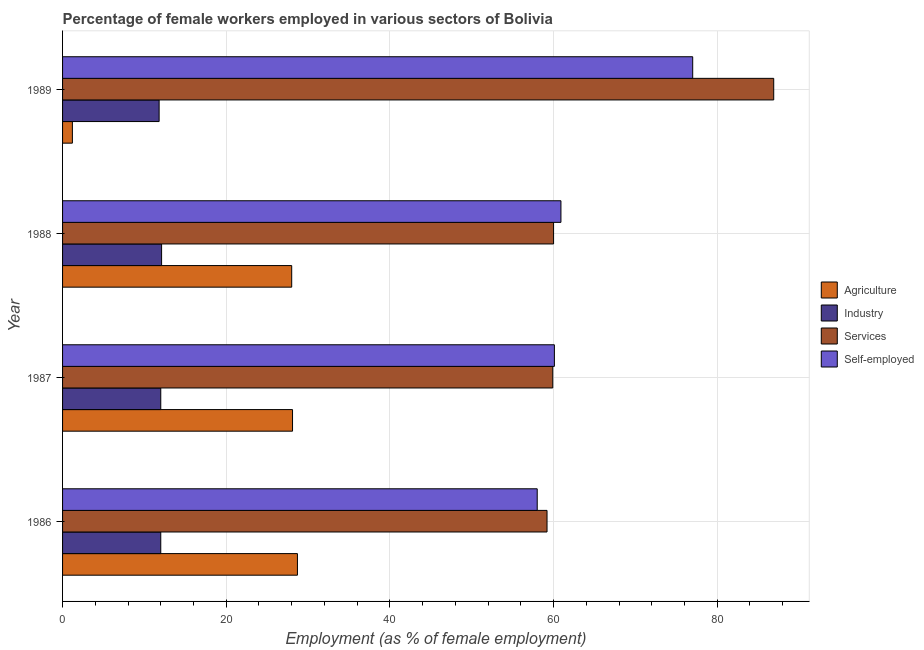How many bars are there on the 4th tick from the top?
Offer a terse response. 4. How many bars are there on the 2nd tick from the bottom?
Give a very brief answer. 4. What is the label of the 1st group of bars from the top?
Give a very brief answer. 1989. What is the percentage of female workers in services in 1987?
Offer a terse response. 59.9. Across all years, what is the maximum percentage of female workers in industry?
Offer a terse response. 12.1. Across all years, what is the minimum percentage of female workers in industry?
Ensure brevity in your answer.  11.8. In which year was the percentage of female workers in industry minimum?
Give a very brief answer. 1989. What is the total percentage of female workers in agriculture in the graph?
Offer a very short reply. 86. What is the difference between the percentage of female workers in agriculture in 1986 and the percentage of female workers in services in 1987?
Your answer should be compact. -31.2. What is the average percentage of female workers in agriculture per year?
Your answer should be compact. 21.5. In how many years, is the percentage of female workers in services greater than 28 %?
Your response must be concise. 4. What is the difference between the highest and the second highest percentage of female workers in services?
Ensure brevity in your answer.  26.9. Is the sum of the percentage of self employed female workers in 1986 and 1989 greater than the maximum percentage of female workers in industry across all years?
Offer a very short reply. Yes. Is it the case that in every year, the sum of the percentage of self employed female workers and percentage of female workers in agriculture is greater than the sum of percentage of female workers in industry and percentage of female workers in services?
Your response must be concise. Yes. What does the 4th bar from the top in 1988 represents?
Make the answer very short. Agriculture. What does the 3rd bar from the bottom in 1989 represents?
Your answer should be compact. Services. Is it the case that in every year, the sum of the percentage of female workers in agriculture and percentage of female workers in industry is greater than the percentage of female workers in services?
Offer a very short reply. No. Are all the bars in the graph horizontal?
Provide a succinct answer. Yes. How many years are there in the graph?
Provide a short and direct response. 4. What is the difference between two consecutive major ticks on the X-axis?
Give a very brief answer. 20. Does the graph contain grids?
Give a very brief answer. Yes. Where does the legend appear in the graph?
Offer a terse response. Center right. What is the title of the graph?
Your answer should be very brief. Percentage of female workers employed in various sectors of Bolivia. Does "International Development Association" appear as one of the legend labels in the graph?
Your answer should be very brief. No. What is the label or title of the X-axis?
Provide a short and direct response. Employment (as % of female employment). What is the Employment (as % of female employment) of Agriculture in 1986?
Your answer should be very brief. 28.7. What is the Employment (as % of female employment) of Services in 1986?
Keep it short and to the point. 59.2. What is the Employment (as % of female employment) of Agriculture in 1987?
Give a very brief answer. 28.1. What is the Employment (as % of female employment) of Industry in 1987?
Ensure brevity in your answer.  12. What is the Employment (as % of female employment) in Services in 1987?
Keep it short and to the point. 59.9. What is the Employment (as % of female employment) in Self-employed in 1987?
Offer a terse response. 60.1. What is the Employment (as % of female employment) of Agriculture in 1988?
Offer a very short reply. 28. What is the Employment (as % of female employment) in Industry in 1988?
Your response must be concise. 12.1. What is the Employment (as % of female employment) of Services in 1988?
Offer a very short reply. 60. What is the Employment (as % of female employment) of Self-employed in 1988?
Your response must be concise. 60.9. What is the Employment (as % of female employment) of Agriculture in 1989?
Keep it short and to the point. 1.2. What is the Employment (as % of female employment) of Industry in 1989?
Your answer should be very brief. 11.8. What is the Employment (as % of female employment) of Services in 1989?
Offer a terse response. 86.9. What is the Employment (as % of female employment) in Self-employed in 1989?
Ensure brevity in your answer.  77. Across all years, what is the maximum Employment (as % of female employment) of Agriculture?
Your answer should be compact. 28.7. Across all years, what is the maximum Employment (as % of female employment) of Industry?
Your answer should be very brief. 12.1. Across all years, what is the maximum Employment (as % of female employment) of Services?
Give a very brief answer. 86.9. Across all years, what is the minimum Employment (as % of female employment) in Agriculture?
Ensure brevity in your answer.  1.2. Across all years, what is the minimum Employment (as % of female employment) of Industry?
Offer a very short reply. 11.8. Across all years, what is the minimum Employment (as % of female employment) of Services?
Offer a terse response. 59.2. What is the total Employment (as % of female employment) of Industry in the graph?
Ensure brevity in your answer.  47.9. What is the total Employment (as % of female employment) in Services in the graph?
Keep it short and to the point. 266. What is the total Employment (as % of female employment) of Self-employed in the graph?
Your response must be concise. 256. What is the difference between the Employment (as % of female employment) of Agriculture in 1986 and that in 1987?
Provide a short and direct response. 0.6. What is the difference between the Employment (as % of female employment) in Industry in 1986 and that in 1987?
Offer a very short reply. 0. What is the difference between the Employment (as % of female employment) of Services in 1986 and that in 1987?
Keep it short and to the point. -0.7. What is the difference between the Employment (as % of female employment) of Self-employed in 1986 and that in 1987?
Make the answer very short. -2.1. What is the difference between the Employment (as % of female employment) of Agriculture in 1986 and that in 1989?
Make the answer very short. 27.5. What is the difference between the Employment (as % of female employment) in Services in 1986 and that in 1989?
Offer a terse response. -27.7. What is the difference between the Employment (as % of female employment) in Agriculture in 1987 and that in 1988?
Your answer should be compact. 0.1. What is the difference between the Employment (as % of female employment) in Industry in 1987 and that in 1988?
Make the answer very short. -0.1. What is the difference between the Employment (as % of female employment) of Services in 1987 and that in 1988?
Offer a very short reply. -0.1. What is the difference between the Employment (as % of female employment) of Agriculture in 1987 and that in 1989?
Offer a terse response. 26.9. What is the difference between the Employment (as % of female employment) in Industry in 1987 and that in 1989?
Your answer should be very brief. 0.2. What is the difference between the Employment (as % of female employment) in Services in 1987 and that in 1989?
Make the answer very short. -27. What is the difference between the Employment (as % of female employment) of Self-employed in 1987 and that in 1989?
Keep it short and to the point. -16.9. What is the difference between the Employment (as % of female employment) of Agriculture in 1988 and that in 1989?
Provide a succinct answer. 26.8. What is the difference between the Employment (as % of female employment) in Services in 1988 and that in 1989?
Offer a very short reply. -26.9. What is the difference between the Employment (as % of female employment) of Self-employed in 1988 and that in 1989?
Your answer should be compact. -16.1. What is the difference between the Employment (as % of female employment) in Agriculture in 1986 and the Employment (as % of female employment) in Industry in 1987?
Give a very brief answer. 16.7. What is the difference between the Employment (as % of female employment) of Agriculture in 1986 and the Employment (as % of female employment) of Services in 1987?
Ensure brevity in your answer.  -31.2. What is the difference between the Employment (as % of female employment) of Agriculture in 1986 and the Employment (as % of female employment) of Self-employed in 1987?
Keep it short and to the point. -31.4. What is the difference between the Employment (as % of female employment) of Industry in 1986 and the Employment (as % of female employment) of Services in 1987?
Make the answer very short. -47.9. What is the difference between the Employment (as % of female employment) of Industry in 1986 and the Employment (as % of female employment) of Self-employed in 1987?
Offer a terse response. -48.1. What is the difference between the Employment (as % of female employment) in Agriculture in 1986 and the Employment (as % of female employment) in Services in 1988?
Your response must be concise. -31.3. What is the difference between the Employment (as % of female employment) in Agriculture in 1986 and the Employment (as % of female employment) in Self-employed in 1988?
Your answer should be very brief. -32.2. What is the difference between the Employment (as % of female employment) of Industry in 1986 and the Employment (as % of female employment) of Services in 1988?
Ensure brevity in your answer.  -48. What is the difference between the Employment (as % of female employment) of Industry in 1986 and the Employment (as % of female employment) of Self-employed in 1988?
Give a very brief answer. -48.9. What is the difference between the Employment (as % of female employment) in Agriculture in 1986 and the Employment (as % of female employment) in Services in 1989?
Your answer should be very brief. -58.2. What is the difference between the Employment (as % of female employment) of Agriculture in 1986 and the Employment (as % of female employment) of Self-employed in 1989?
Offer a very short reply. -48.3. What is the difference between the Employment (as % of female employment) of Industry in 1986 and the Employment (as % of female employment) of Services in 1989?
Offer a very short reply. -74.9. What is the difference between the Employment (as % of female employment) of Industry in 1986 and the Employment (as % of female employment) of Self-employed in 1989?
Offer a terse response. -65. What is the difference between the Employment (as % of female employment) in Services in 1986 and the Employment (as % of female employment) in Self-employed in 1989?
Offer a terse response. -17.8. What is the difference between the Employment (as % of female employment) of Agriculture in 1987 and the Employment (as % of female employment) of Industry in 1988?
Your response must be concise. 16. What is the difference between the Employment (as % of female employment) of Agriculture in 1987 and the Employment (as % of female employment) of Services in 1988?
Your answer should be compact. -31.9. What is the difference between the Employment (as % of female employment) in Agriculture in 1987 and the Employment (as % of female employment) in Self-employed in 1988?
Provide a succinct answer. -32.8. What is the difference between the Employment (as % of female employment) in Industry in 1987 and the Employment (as % of female employment) in Services in 1988?
Make the answer very short. -48. What is the difference between the Employment (as % of female employment) of Industry in 1987 and the Employment (as % of female employment) of Self-employed in 1988?
Your answer should be compact. -48.9. What is the difference between the Employment (as % of female employment) in Services in 1987 and the Employment (as % of female employment) in Self-employed in 1988?
Provide a short and direct response. -1. What is the difference between the Employment (as % of female employment) of Agriculture in 1987 and the Employment (as % of female employment) of Industry in 1989?
Your answer should be very brief. 16.3. What is the difference between the Employment (as % of female employment) in Agriculture in 1987 and the Employment (as % of female employment) in Services in 1989?
Offer a terse response. -58.8. What is the difference between the Employment (as % of female employment) of Agriculture in 1987 and the Employment (as % of female employment) of Self-employed in 1989?
Offer a very short reply. -48.9. What is the difference between the Employment (as % of female employment) of Industry in 1987 and the Employment (as % of female employment) of Services in 1989?
Your answer should be very brief. -74.9. What is the difference between the Employment (as % of female employment) of Industry in 1987 and the Employment (as % of female employment) of Self-employed in 1989?
Provide a short and direct response. -65. What is the difference between the Employment (as % of female employment) of Services in 1987 and the Employment (as % of female employment) of Self-employed in 1989?
Ensure brevity in your answer.  -17.1. What is the difference between the Employment (as % of female employment) of Agriculture in 1988 and the Employment (as % of female employment) of Services in 1989?
Offer a terse response. -58.9. What is the difference between the Employment (as % of female employment) in Agriculture in 1988 and the Employment (as % of female employment) in Self-employed in 1989?
Give a very brief answer. -49. What is the difference between the Employment (as % of female employment) in Industry in 1988 and the Employment (as % of female employment) in Services in 1989?
Your answer should be compact. -74.8. What is the difference between the Employment (as % of female employment) in Industry in 1988 and the Employment (as % of female employment) in Self-employed in 1989?
Give a very brief answer. -64.9. What is the average Employment (as % of female employment) of Agriculture per year?
Keep it short and to the point. 21.5. What is the average Employment (as % of female employment) in Industry per year?
Give a very brief answer. 11.97. What is the average Employment (as % of female employment) of Services per year?
Your answer should be compact. 66.5. In the year 1986, what is the difference between the Employment (as % of female employment) of Agriculture and Employment (as % of female employment) of Industry?
Provide a short and direct response. 16.7. In the year 1986, what is the difference between the Employment (as % of female employment) in Agriculture and Employment (as % of female employment) in Services?
Keep it short and to the point. -30.5. In the year 1986, what is the difference between the Employment (as % of female employment) of Agriculture and Employment (as % of female employment) of Self-employed?
Ensure brevity in your answer.  -29.3. In the year 1986, what is the difference between the Employment (as % of female employment) in Industry and Employment (as % of female employment) in Services?
Your answer should be compact. -47.2. In the year 1986, what is the difference between the Employment (as % of female employment) in Industry and Employment (as % of female employment) in Self-employed?
Ensure brevity in your answer.  -46. In the year 1986, what is the difference between the Employment (as % of female employment) in Services and Employment (as % of female employment) in Self-employed?
Make the answer very short. 1.2. In the year 1987, what is the difference between the Employment (as % of female employment) of Agriculture and Employment (as % of female employment) of Services?
Your answer should be very brief. -31.8. In the year 1987, what is the difference between the Employment (as % of female employment) of Agriculture and Employment (as % of female employment) of Self-employed?
Your answer should be very brief. -32. In the year 1987, what is the difference between the Employment (as % of female employment) in Industry and Employment (as % of female employment) in Services?
Your answer should be very brief. -47.9. In the year 1987, what is the difference between the Employment (as % of female employment) in Industry and Employment (as % of female employment) in Self-employed?
Your answer should be very brief. -48.1. In the year 1988, what is the difference between the Employment (as % of female employment) in Agriculture and Employment (as % of female employment) in Industry?
Offer a very short reply. 15.9. In the year 1988, what is the difference between the Employment (as % of female employment) in Agriculture and Employment (as % of female employment) in Services?
Your response must be concise. -32. In the year 1988, what is the difference between the Employment (as % of female employment) of Agriculture and Employment (as % of female employment) of Self-employed?
Offer a terse response. -32.9. In the year 1988, what is the difference between the Employment (as % of female employment) of Industry and Employment (as % of female employment) of Services?
Your response must be concise. -47.9. In the year 1988, what is the difference between the Employment (as % of female employment) of Industry and Employment (as % of female employment) of Self-employed?
Keep it short and to the point. -48.8. In the year 1988, what is the difference between the Employment (as % of female employment) in Services and Employment (as % of female employment) in Self-employed?
Offer a terse response. -0.9. In the year 1989, what is the difference between the Employment (as % of female employment) in Agriculture and Employment (as % of female employment) in Industry?
Your answer should be compact. -10.6. In the year 1989, what is the difference between the Employment (as % of female employment) of Agriculture and Employment (as % of female employment) of Services?
Your answer should be compact. -85.7. In the year 1989, what is the difference between the Employment (as % of female employment) of Agriculture and Employment (as % of female employment) of Self-employed?
Make the answer very short. -75.8. In the year 1989, what is the difference between the Employment (as % of female employment) of Industry and Employment (as % of female employment) of Services?
Ensure brevity in your answer.  -75.1. In the year 1989, what is the difference between the Employment (as % of female employment) of Industry and Employment (as % of female employment) of Self-employed?
Offer a terse response. -65.2. What is the ratio of the Employment (as % of female employment) of Agriculture in 1986 to that in 1987?
Give a very brief answer. 1.02. What is the ratio of the Employment (as % of female employment) in Industry in 1986 to that in 1987?
Offer a very short reply. 1. What is the ratio of the Employment (as % of female employment) of Services in 1986 to that in 1987?
Offer a very short reply. 0.99. What is the ratio of the Employment (as % of female employment) in Self-employed in 1986 to that in 1987?
Make the answer very short. 0.97. What is the ratio of the Employment (as % of female employment) in Agriculture in 1986 to that in 1988?
Provide a short and direct response. 1.02. What is the ratio of the Employment (as % of female employment) of Industry in 1986 to that in 1988?
Offer a terse response. 0.99. What is the ratio of the Employment (as % of female employment) of Services in 1986 to that in 1988?
Give a very brief answer. 0.99. What is the ratio of the Employment (as % of female employment) of Agriculture in 1986 to that in 1989?
Offer a terse response. 23.92. What is the ratio of the Employment (as % of female employment) of Industry in 1986 to that in 1989?
Your answer should be very brief. 1.02. What is the ratio of the Employment (as % of female employment) of Services in 1986 to that in 1989?
Your answer should be very brief. 0.68. What is the ratio of the Employment (as % of female employment) in Self-employed in 1986 to that in 1989?
Keep it short and to the point. 0.75. What is the ratio of the Employment (as % of female employment) in Agriculture in 1987 to that in 1988?
Your answer should be very brief. 1. What is the ratio of the Employment (as % of female employment) of Services in 1987 to that in 1988?
Make the answer very short. 1. What is the ratio of the Employment (as % of female employment) in Self-employed in 1987 to that in 1988?
Your answer should be compact. 0.99. What is the ratio of the Employment (as % of female employment) in Agriculture in 1987 to that in 1989?
Provide a short and direct response. 23.42. What is the ratio of the Employment (as % of female employment) of Industry in 1987 to that in 1989?
Your answer should be compact. 1.02. What is the ratio of the Employment (as % of female employment) in Services in 1987 to that in 1989?
Ensure brevity in your answer.  0.69. What is the ratio of the Employment (as % of female employment) of Self-employed in 1987 to that in 1989?
Your answer should be very brief. 0.78. What is the ratio of the Employment (as % of female employment) in Agriculture in 1988 to that in 1989?
Make the answer very short. 23.33. What is the ratio of the Employment (as % of female employment) of Industry in 1988 to that in 1989?
Your response must be concise. 1.03. What is the ratio of the Employment (as % of female employment) in Services in 1988 to that in 1989?
Your answer should be compact. 0.69. What is the ratio of the Employment (as % of female employment) of Self-employed in 1988 to that in 1989?
Keep it short and to the point. 0.79. What is the difference between the highest and the second highest Employment (as % of female employment) of Services?
Your answer should be very brief. 26.9. What is the difference between the highest and the lowest Employment (as % of female employment) in Agriculture?
Make the answer very short. 27.5. What is the difference between the highest and the lowest Employment (as % of female employment) of Services?
Offer a terse response. 27.7. What is the difference between the highest and the lowest Employment (as % of female employment) of Self-employed?
Offer a very short reply. 19. 